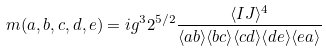<formula> <loc_0><loc_0><loc_500><loc_500>m ( a , b , c , d , e ) = i g ^ { 3 } 2 ^ { 5 / 2 } \frac { \langle I J \rangle ^ { 4 } } { \langle a b \rangle \langle b c \rangle \langle c d \rangle \langle d e \rangle \langle e a \rangle }</formula> 